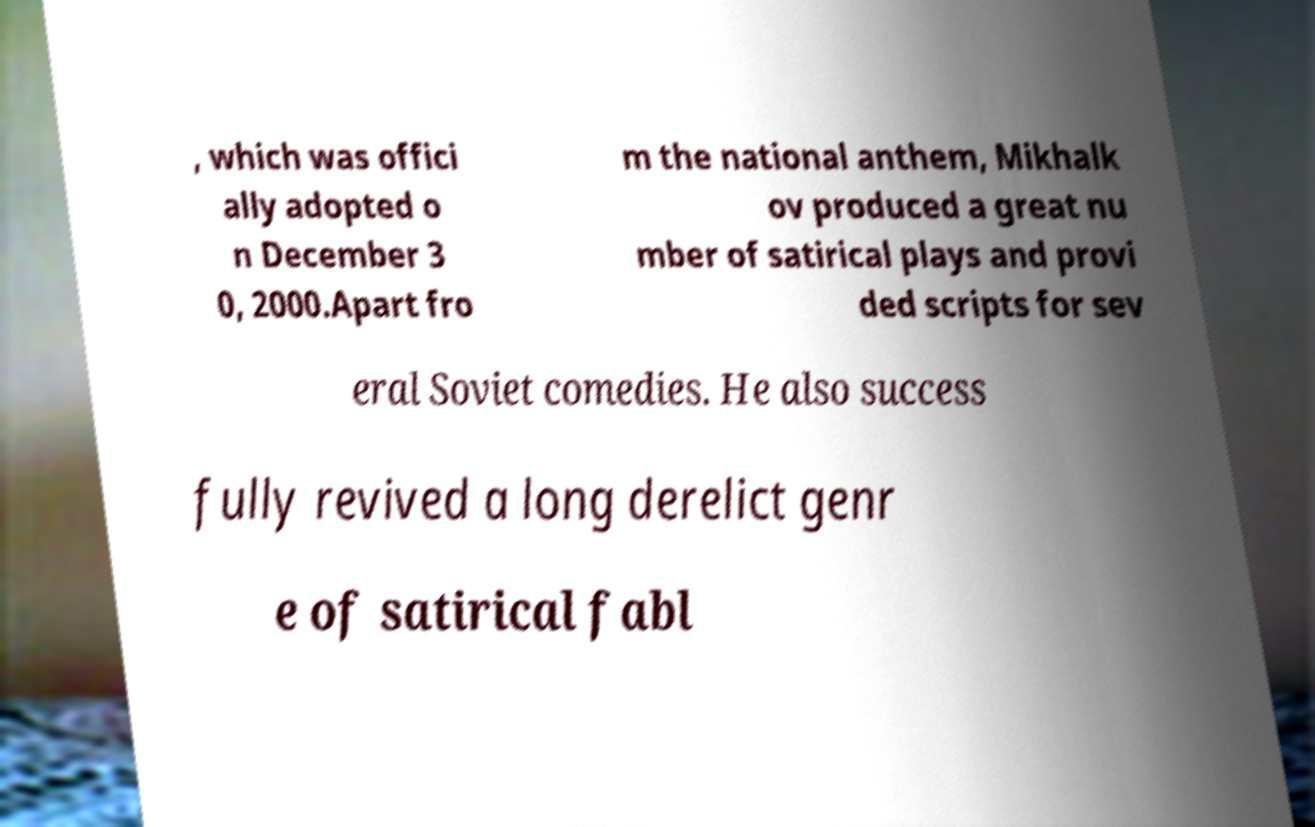Can you read and provide the text displayed in the image?This photo seems to have some interesting text. Can you extract and type it out for me? , which was offici ally adopted o n December 3 0, 2000.Apart fro m the national anthem, Mikhalk ov produced a great nu mber of satirical plays and provi ded scripts for sev eral Soviet comedies. He also success fully revived a long derelict genr e of satirical fabl 